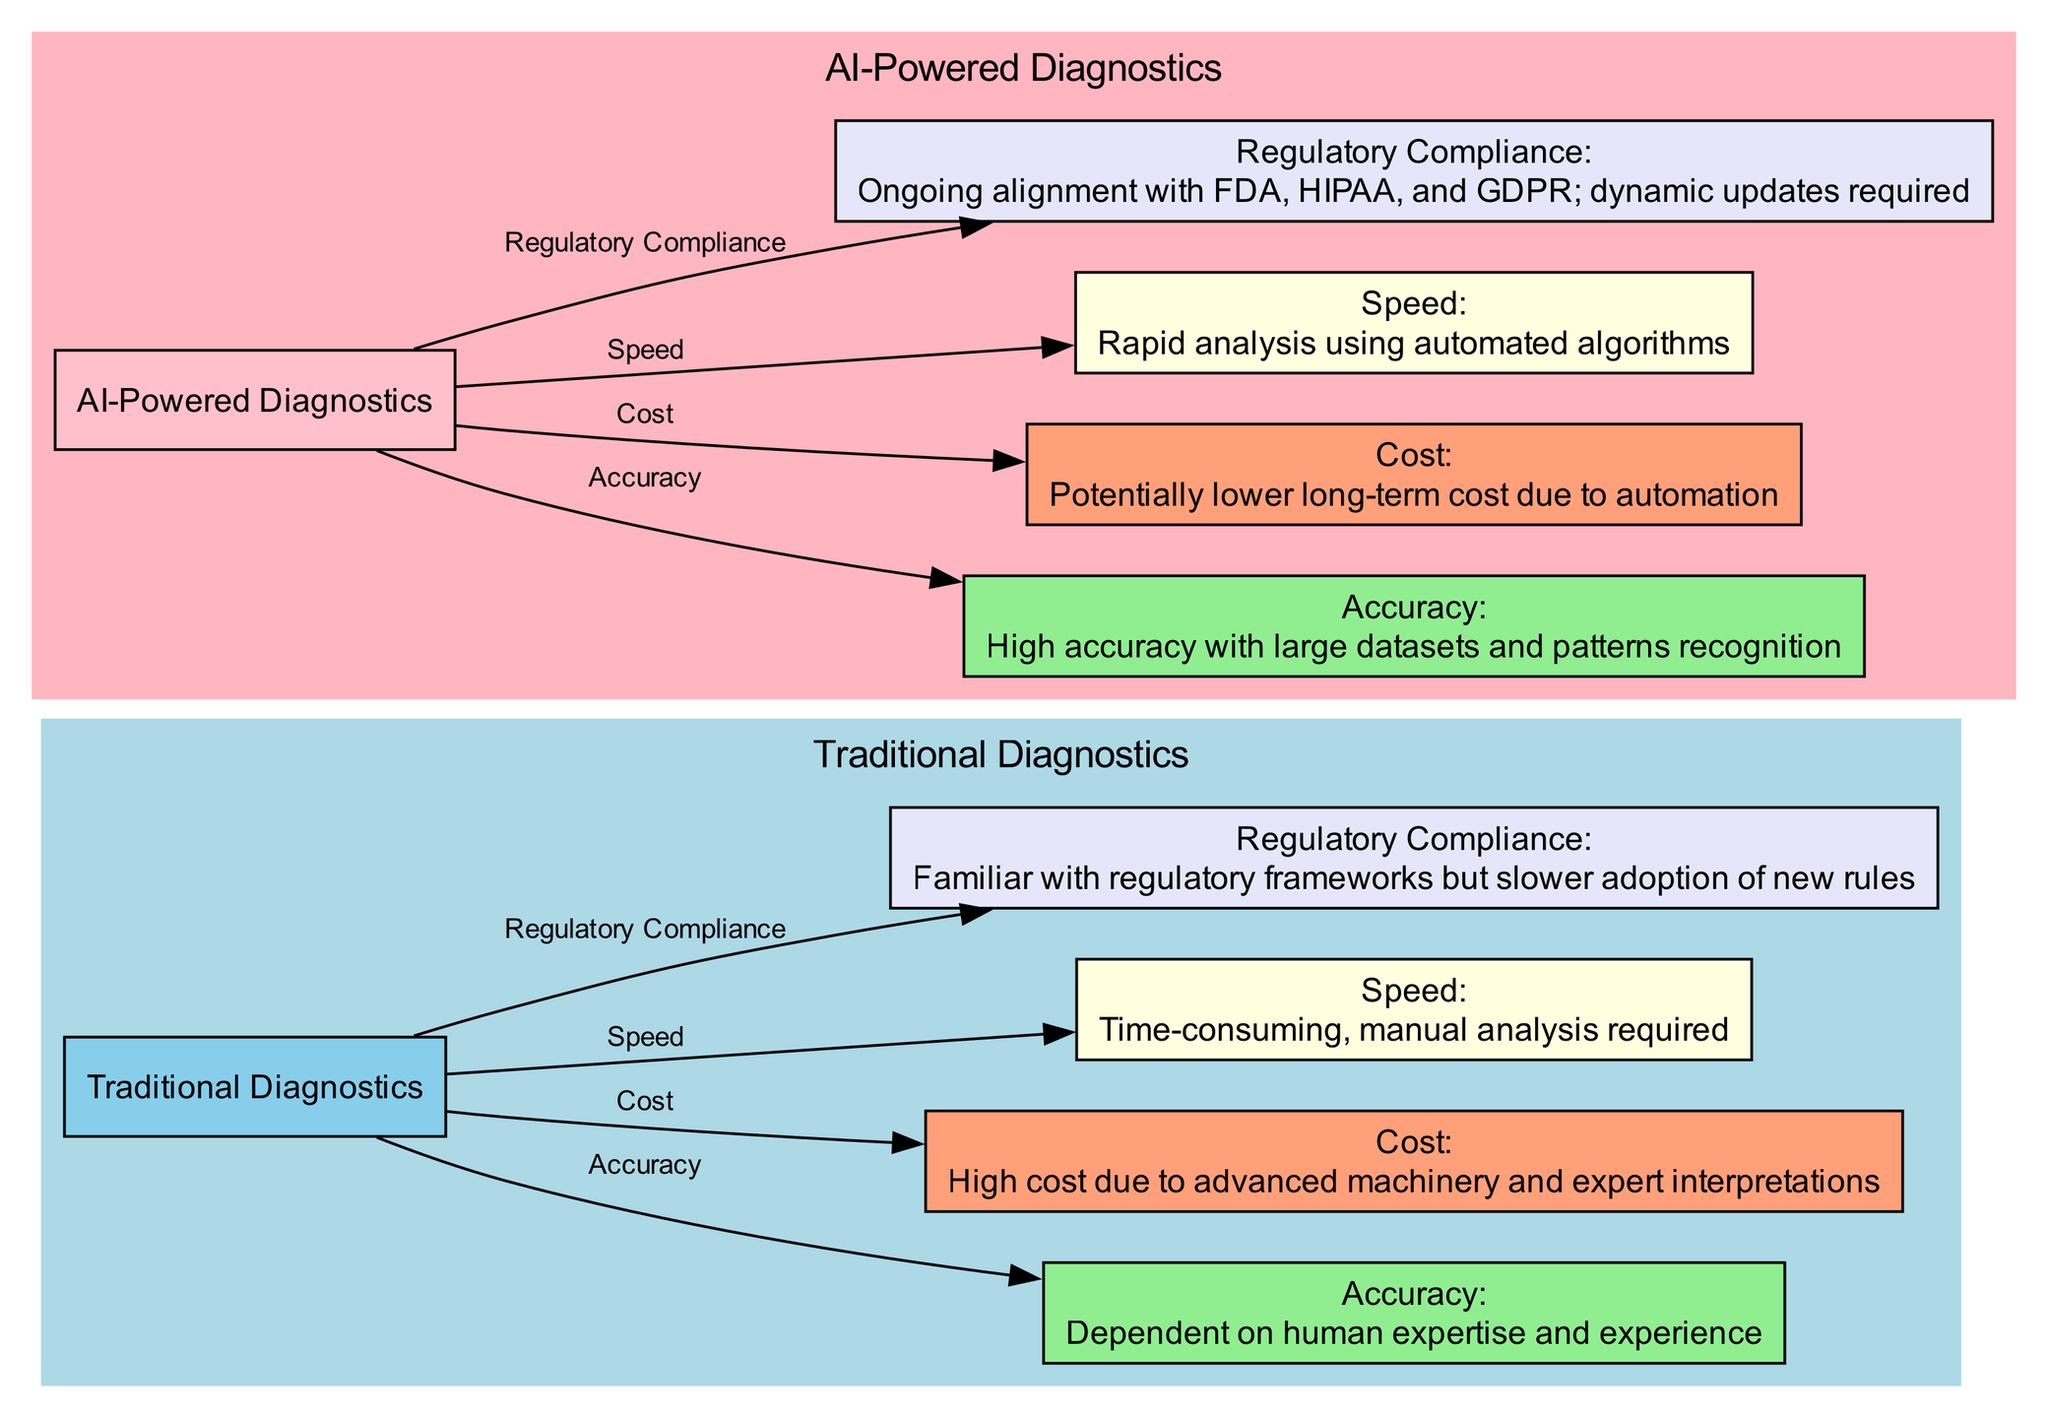What are the two main types of diagnostic tools depicted in the diagram? The diagram shows two main nodes: one for "Traditional Diagnostics" and another for "AI-Powered Diagnostics". These are the central elements representing traditional and AI-driven methods.
Answer: Traditional Diagnostics, AI-Powered Diagnostics How many nodes are present in the traditional diagnostics section? In the cluster for "Traditional Diagnostics," there are a total of five nodes: Accuracy, Cost, Speed, Compliance, and the main node itself.
Answer: Five What is the description of AI-Powered Diagnostics regarding accuracy? The node for "Accuracy" under AI-Powered Diagnostics states "High accuracy with large datasets and patterns recognition." This reflects the quality of AI in diagnostics.
Answer: High accuracy with large datasets and patterns recognition Which diagnostic method is associated with potentially lower long-term costs? The node labeled "Cost" under AI-Powered Diagnostics informs that it is associated with "Potentially lower long-term cost due to automation", indicating it may save money over time.
Answer: AI-Powered Diagnostics What is the relationship between traditional diagnostics and the speed of analysis? The diagram shows an edge labeled "Speed" linking "Traditional Diagnostics" to "Speed", describing it as "Time-consuming, manual analysis required". This indicates that traditional methods are slower.
Answer: Time-consuming, manual analysis required How does regulatory compliance compare between the two diagnostic methods? The "Regulatory Compliance" node for Traditional Diagnostics indicates familiarity with frameworks but slower adoption. In contrast, the AI-Powered Diagnostics focus on ongoing alignment and dynamic updates, highlighting a proactive approach.
Answer: Slower adoption vs. dynamic updates Which method has a subgraph marked in light blue? The node is in a subgraph labeled "Traditional Diagnostics", which has been formatted with a light blue background to differentiate it visually from the AI-Powered Diagnostics section.
Answer: Traditional Diagnostics What is the primary challenge mentioned for regulatory compliance in AI-Powered Diagnostics? Under the "Regulatory Compliance" node linked to AI-Powered Diagnostics, it states "Ongoing alignment with FDA, HIPAA, and GDPR; dynamic updates required", indicating the complexity of keeping up with regulations.
Answer: Ongoing alignment with FDA, HIPAA, and GDPR; dynamic updates required 